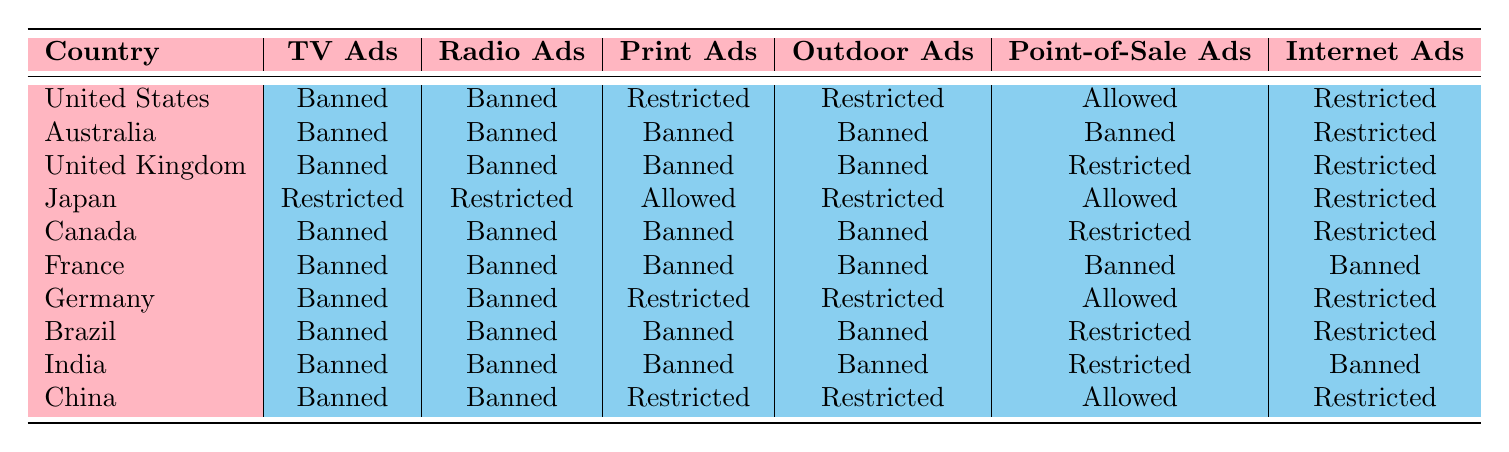What are the tobacco advertising restrictions in the United Kingdom? According to the table, in the United Kingdom, tobacco advertising is banned on TV, radio, print, and outdoor. Point-of-sale advertising is restricted, while internet ads are also restricted.
Answer: Banned Which countries have banned tobacco ads across all media channels listed? By examining the table, we see that Australia, Canada, France, Brazil, and India have banned tobacco ads across TV, radio, print, outdoor, and point-of-sale channels.
Answer: Australia, Canada, France, Brazil, India Is it true that Japan allows print ads for tobacco products? Looking at the table, Japan has "Allowed" for print ads, indicating that print ads for tobacco products are permitted in Japan.
Answer: Yes How many countries allow point-of-sale ads for tobacco products? From the table, we can list the countries that permit point-of-sale ads: United States, Japan, Germany, and China. This gives a total count of four countries allowing such ads.
Answer: 4 Which country has the least restrictions on tobacco advertising? Analyzing the table, Japan shows the least overall restrictions; it allows print ads, point-of-sale ads, and has various restrictions on other types of ads. Thus, Japan has the most lenient policies compared to others.
Answer: Japan What percentage of the countries listed have banned outdoor tobacco ads? There are 10 countries in total, and 7 of them have banned outdoor tobacco ads. The percentage is calculated as (7/10) * 100 = 70%.
Answer: 70% How does the restriction on internet ads in the United States compare to other countries? The United States has restricted internet ads. When compared with countries like Australia and France, which have banned all ads including internet ads, the U.S. has less strict regulation on internet advertising for tobacco.
Answer: Less strict Which country has the most comprehensive bans on tobacco advertising? France stands out because it has a blanket ban on all forms of advertising: TV, radio, print, outdoor, point-of-sale, and internet ads. This makes it the country with the most comprehensive bans.
Answer: France 